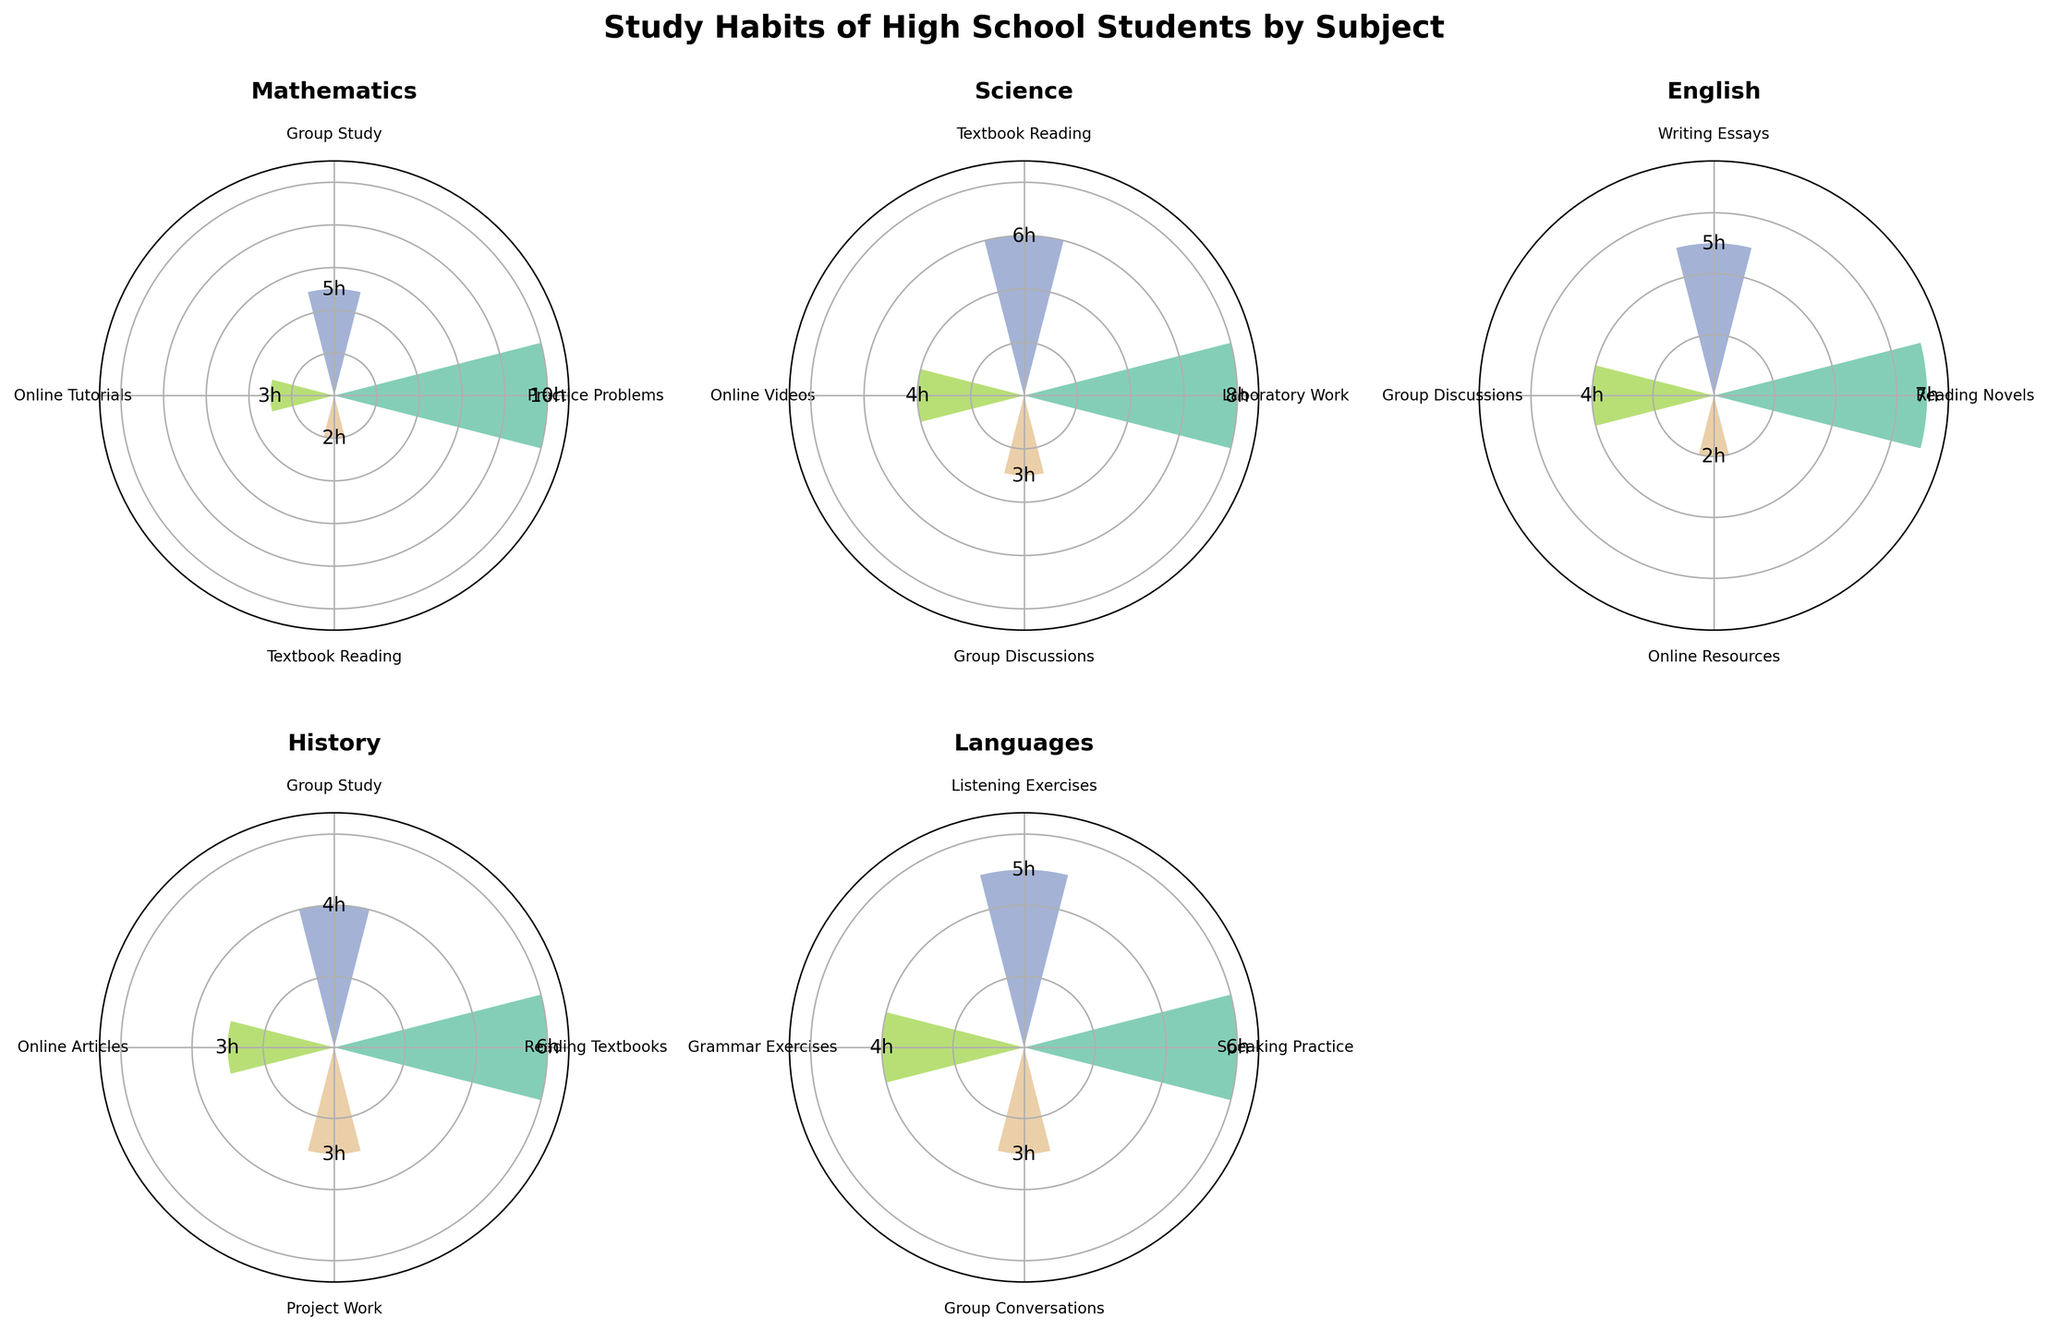What is the title of the figure? The title is typically placed at the top of the figure and describes the overall topic. Here, it states: "Study Habits of High School Students by Subject"
Answer: Study Habits of High School Students by Subject Which subject has the highest single duration activity? To find this, identify the highest bar among all subplots. The highest bar is in Mathematics, representing "Practice Problems" for 10 hours.
Answer: Mathematics What is the duration difference between the longest and shortest activity within Science? The longest activity in Science is "Laboratory Work" (8 hours), and the shortest is "Group Discussions" (3 hours). The difference is 8 - 3 = 5 hours.
Answer: 5 hours Which activities in English have the same duration? According to the figure, "Group Discussions" and "Online Resources" both have durations of 4 hours.
Answer: Group Discussions and Online Resources What is the average duration of activities in History? Sum the durations of activities in History: 6 + 4 + 3 + 3 = 16 hours. There are 4 activities, so the average is 16 / 4 = 4 hours.
Answer: 4 hours Which subject includes "Speaking Practice" as an activity, and what's its duration? By looking at the labels in the subplots, "Speaking Practice" appears in the Languages subplot with a duration of 6 hours.
Answer: Languages, 6 hours Which activity is common between Science and English, and what are their respective durations? The common activity is "Group Discussions". In Science, it has a duration of 3 hours, and in English, 4 hours.
Answer: Group Discussions; 3 hours (Science), 4 hours (English) How many activities have a duration of exactly 3 hours? Identify the bars marked with "3h". They are: "Online Tutorials" (Mathematics), "Group Discussions" (Science), "Online Articles" and "Project Work" (History), "Group Conversations" (Languages). There are 5 activities.
Answer: 5 activities Which subject has the most balanced (least variation in) study durations? By comparing the ranges of durations across subplots, Languages appears most balanced as the durations are close to each other: 6, 5, 4, and 3 hours.
Answer: Languages 